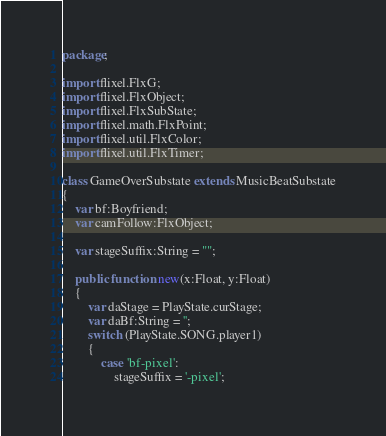<code> <loc_0><loc_0><loc_500><loc_500><_Haxe_>package;

import flixel.FlxG;
import flixel.FlxObject;
import flixel.FlxSubState;
import flixel.math.FlxPoint;
import flixel.util.FlxColor;
import flixel.util.FlxTimer;

class GameOverSubstate extends MusicBeatSubstate
{
	var bf:Boyfriend;
	var camFollow:FlxObject;

	var stageSuffix:String = "";

	public function new(x:Float, y:Float)
	{
		var daStage = PlayState.curStage;
		var daBf:String = '';
		switch (PlayState.SONG.player1)
		{
			case 'bf-pixel':
				stageSuffix = '-pixel';</code> 